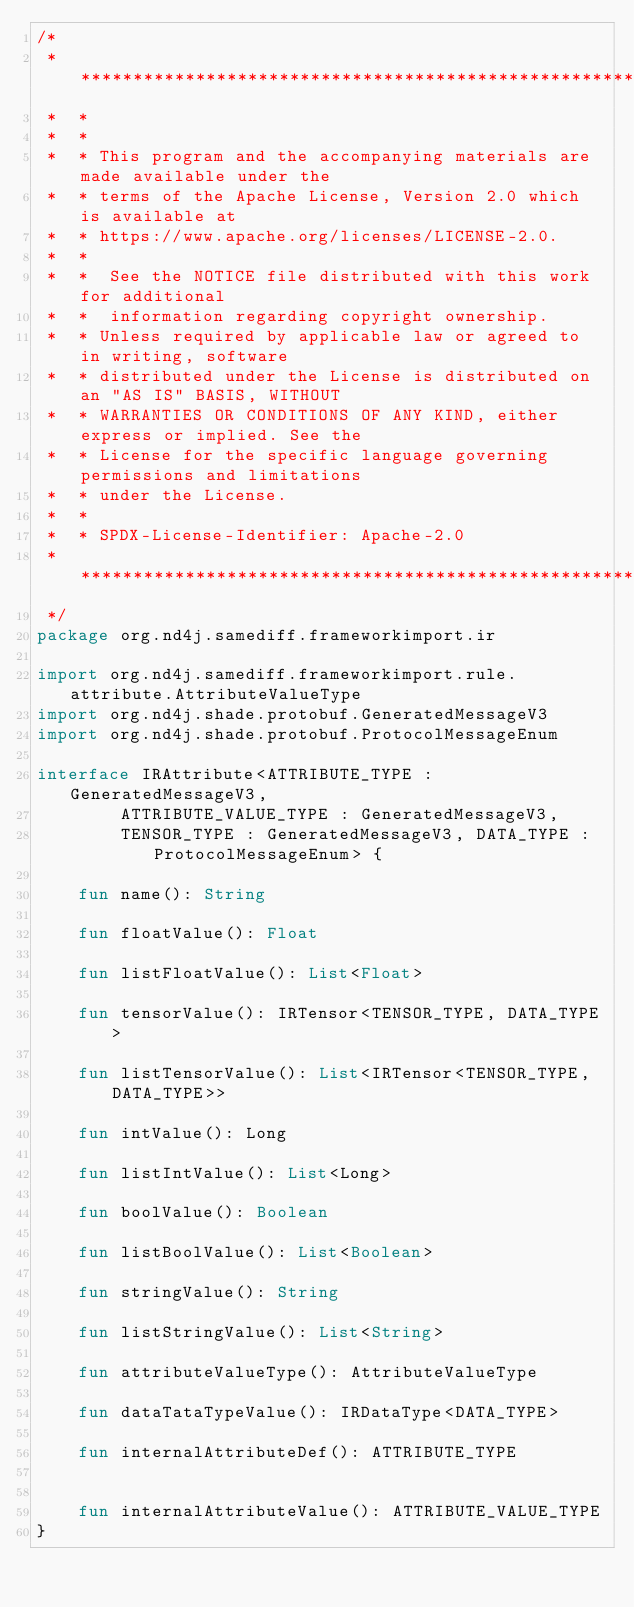Convert code to text. <code><loc_0><loc_0><loc_500><loc_500><_Kotlin_>/*
 *  ******************************************************************************
 *  *
 *  *
 *  * This program and the accompanying materials are made available under the
 *  * terms of the Apache License, Version 2.0 which is available at
 *  * https://www.apache.org/licenses/LICENSE-2.0.
 *  *
 *  *  See the NOTICE file distributed with this work for additional
 *  *  information regarding copyright ownership.
 *  * Unless required by applicable law or agreed to in writing, software
 *  * distributed under the License is distributed on an "AS IS" BASIS, WITHOUT
 *  * WARRANTIES OR CONDITIONS OF ANY KIND, either express or implied. See the
 *  * License for the specific language governing permissions and limitations
 *  * under the License.
 *  *
 *  * SPDX-License-Identifier: Apache-2.0
 *  *****************************************************************************
 */
package org.nd4j.samediff.frameworkimport.ir

import org.nd4j.samediff.frameworkimport.rule.attribute.AttributeValueType
import org.nd4j.shade.protobuf.GeneratedMessageV3
import org.nd4j.shade.protobuf.ProtocolMessageEnum

interface IRAttribute<ATTRIBUTE_TYPE : GeneratedMessageV3,
        ATTRIBUTE_VALUE_TYPE : GeneratedMessageV3,
        TENSOR_TYPE : GeneratedMessageV3, DATA_TYPE : ProtocolMessageEnum> {

    fun name(): String

    fun floatValue(): Float

    fun listFloatValue(): List<Float>

    fun tensorValue(): IRTensor<TENSOR_TYPE, DATA_TYPE>

    fun listTensorValue(): List<IRTensor<TENSOR_TYPE, DATA_TYPE>>

    fun intValue(): Long

    fun listIntValue(): List<Long>

    fun boolValue(): Boolean

    fun listBoolValue(): List<Boolean>

    fun stringValue(): String

    fun listStringValue(): List<String>

    fun attributeValueType(): AttributeValueType

    fun dataTataTypeValue(): IRDataType<DATA_TYPE>

    fun internalAttributeDef(): ATTRIBUTE_TYPE


    fun internalAttributeValue(): ATTRIBUTE_VALUE_TYPE
}</code> 